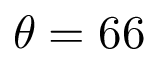<formula> <loc_0><loc_0><loc_500><loc_500>\theta = 6 6</formula> 